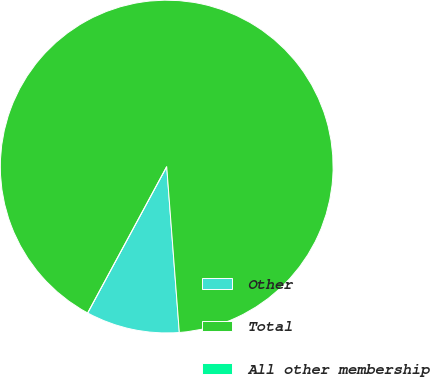Convert chart. <chart><loc_0><loc_0><loc_500><loc_500><pie_chart><fcel>Other<fcel>Total<fcel>All other membership<nl><fcel>9.09%<fcel>90.91%<fcel>0.0%<nl></chart> 